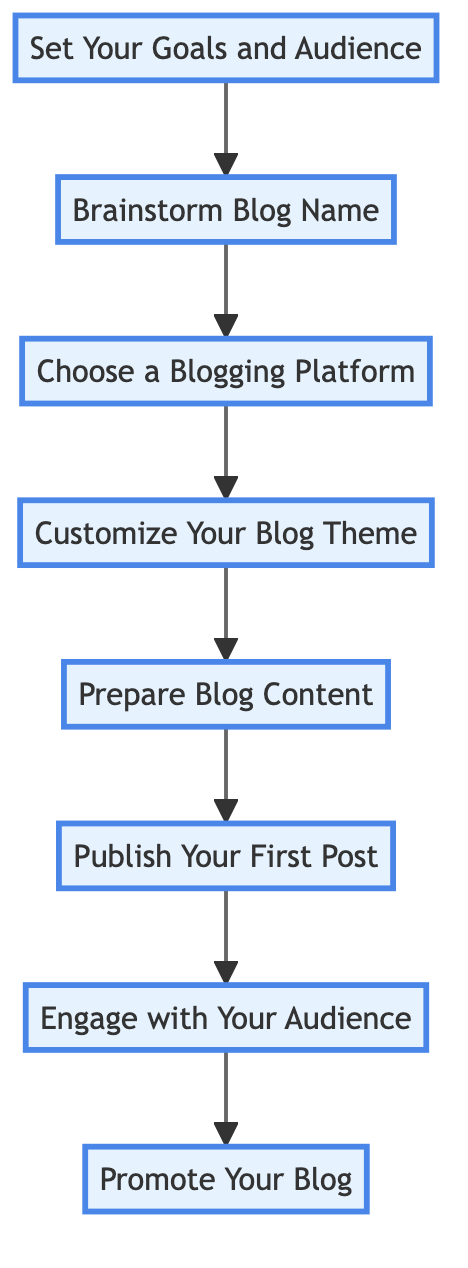What is the first step in creating the blog? The first step in the flow chart is "Set Your Goals and Audience", which is the starting point before any other actions can take place.
Answer: Set Your Goals and Audience How many steps are involved in creating the blog? The diagram lists eight distinct steps, starting from setting goals and culminating in promoting the blog.
Answer: 8 Which step comes immediately after "Prepare Blog Content"? The step that follows "Prepare Blog Content" is "Publish Your First Post", indicating that content preparation leads to publishing.
Answer: Publish Your First Post What is the final action to take in the blog creation process? The last action in the diagram is "Promote Your Blog", which signifies that after engagement, the blog should be shared widely.
Answer: Promote Your Blog Which two steps involve interacting with the audience? The steps that involve audience interaction are "Engage with Your Audience" and "Promote Your Blog", showing the importance of reaching out to readers.
Answer: Engage with Your Audience, Promote Your Blog What should you do before customizing your blog theme? Before customizing the blog theme, you need to "Choose a Blogging Platform", as this is necessary for the setup of the blog itself.
Answer: Choose a Blogging Platform How does "Brainstorm Blog Name" relate to "Set Your Goals and Audience"? "Brainstorm Blog Name" is the second step that follows "Set Your Goals and Audience", meaning that naming occurs after defining your blog's purpose.
Answer: The second step What is the relationship between "Choose a Blogging Platform" and "Publish Your First Post"? "Choose a Blogging Platform" is a prerequisite step to "Publish Your First Post", indicating that the platform must be selected before any content can go live.
Answer: Prerequisite step What theme-related action do you take after choosing a blogging platform? After selecting a blogging platform, the next action is to "Customize Your Blog Theme", which involves personalizing the appearance of the blog.
Answer: Customize Your Blog Theme 